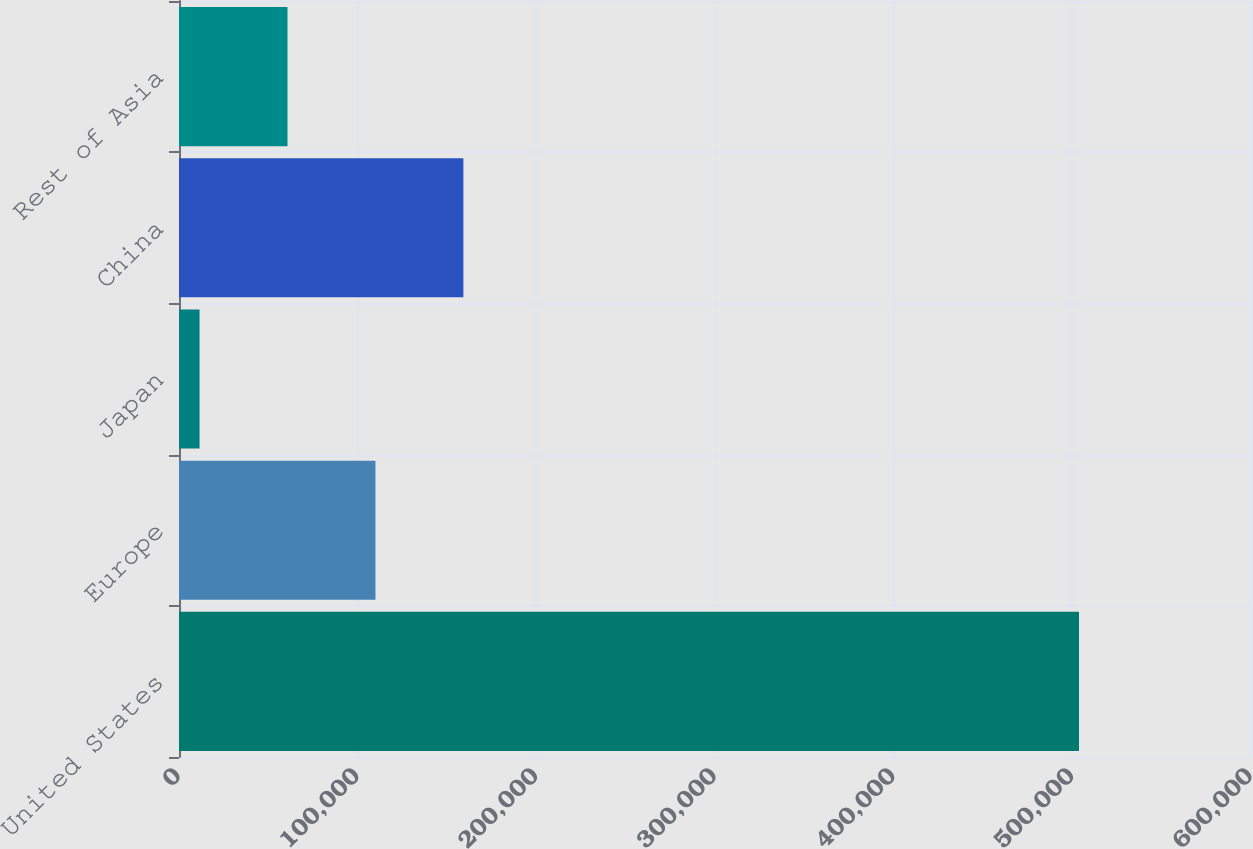Convert chart. <chart><loc_0><loc_0><loc_500><loc_500><bar_chart><fcel>United States<fcel>Europe<fcel>Japan<fcel>China<fcel>Rest of Asia<nl><fcel>503725<fcel>109957<fcel>11515<fcel>159178<fcel>60736<nl></chart> 